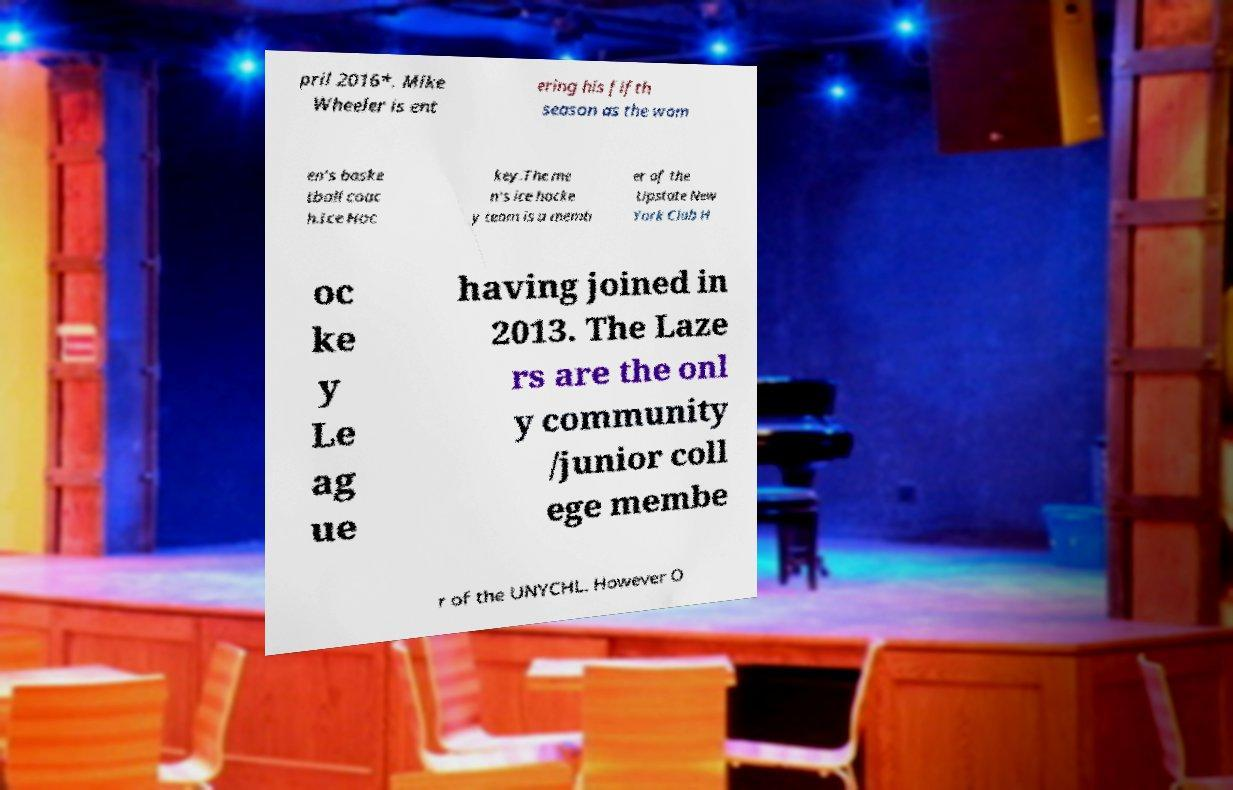There's text embedded in this image that I need extracted. Can you transcribe it verbatim? pril 2016*. Mike Wheeler is ent ering his fifth season as the wom en's baske tball coac h.Ice Hoc key.The me n's ice hocke y team is a memb er of the Upstate New York Club H oc ke y Le ag ue having joined in 2013. The Laze rs are the onl y community /junior coll ege membe r of the UNYCHL. However O 